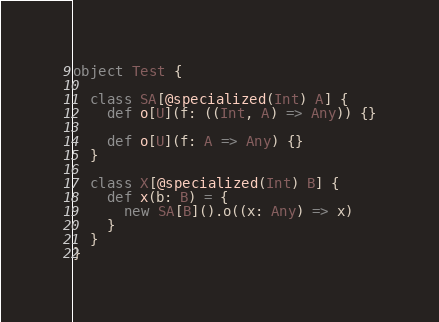<code> <loc_0><loc_0><loc_500><loc_500><_Scala_>object Test {

  class SA[@specialized(Int) A] {
    def o[U](f: ((Int, A) => Any)) {}

    def o[U](f: A => Any) {}
  }

  class X[@specialized(Int) B] {
    def x(b: B) = {
      new SA[B]().o((x: Any) => x)
    }
  }
}

</code> 